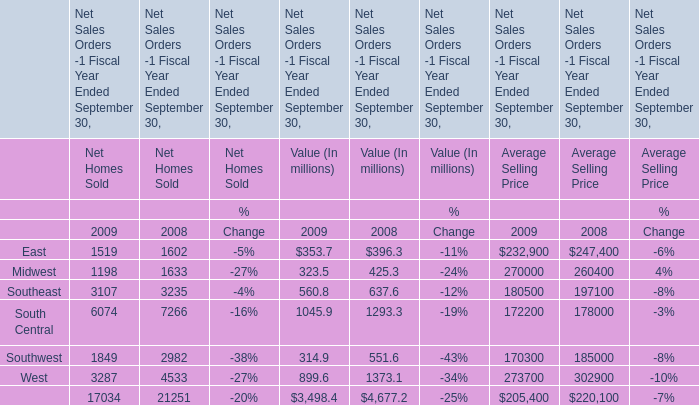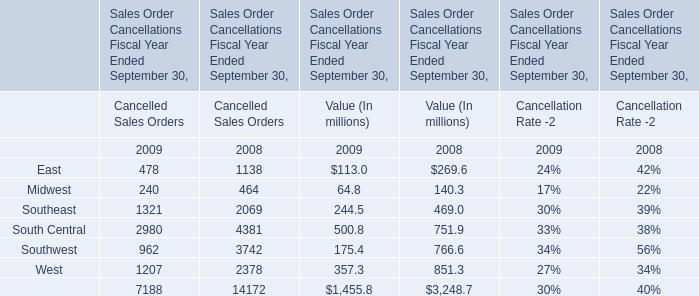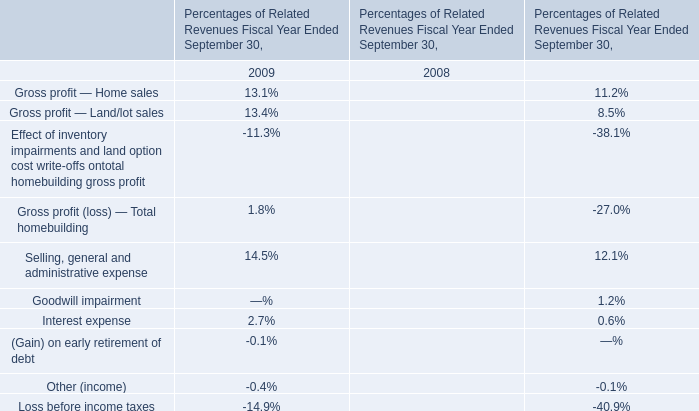When does East for Value (In millions) reach the largest value? 
Answer: 2008. 